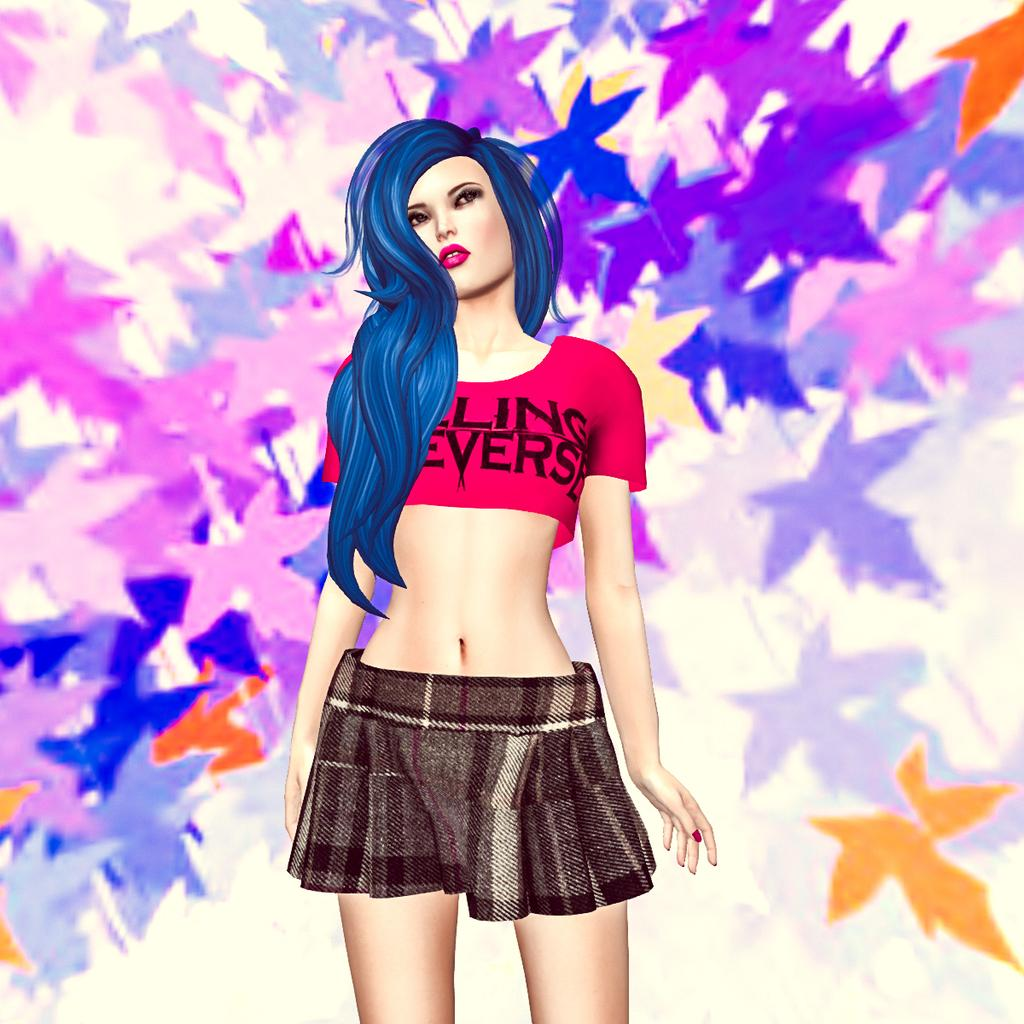<image>
Describe the image concisely. A drawing of a woman with blue hair, a word ending in 'ling' is visible on her crop top. 